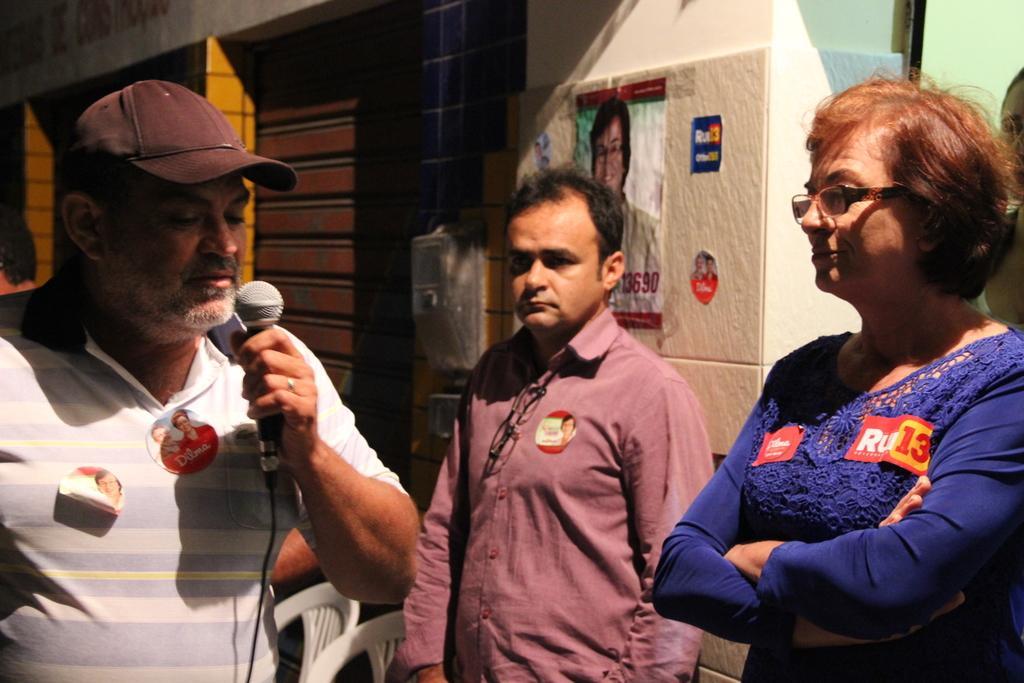How would you summarize this image in a sentence or two? In this picture there are three people standing among them one is a women in blue shirt and the other two are men among them one is holding the mic. 